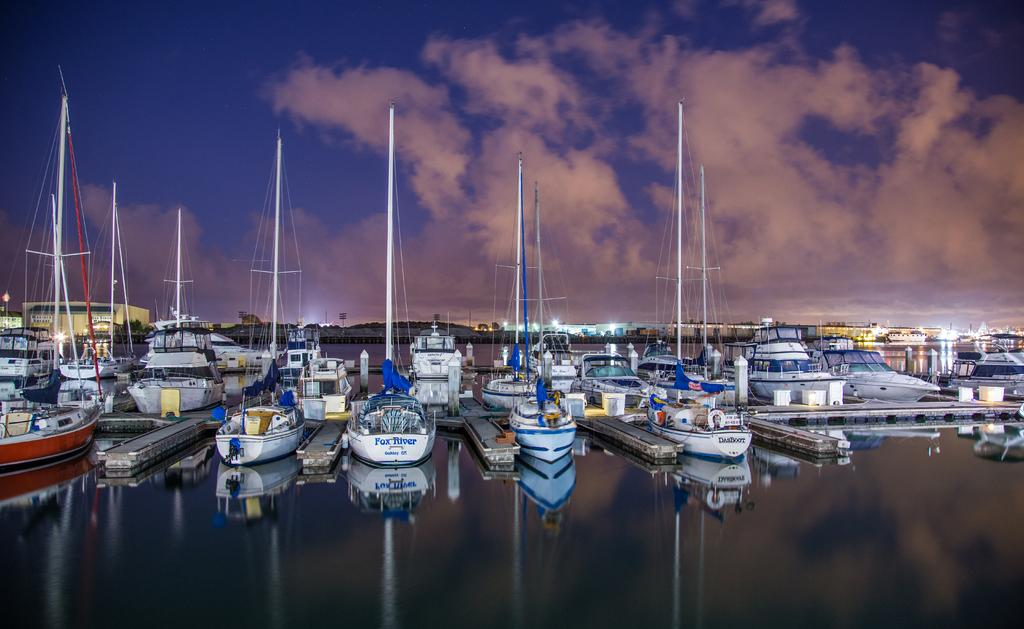What is in the water in the image? There are ships in the water in the image. What can be seen in the background of the image? There are buildings and lights visible in the background. What is visible in the sky in the image? There are clouds in the sky in the image. How many grains of salt can be seen on the girl's teeth in the image? There is no girl or teeth present in the image, so it is not possible to determine the number of grains of salt. 